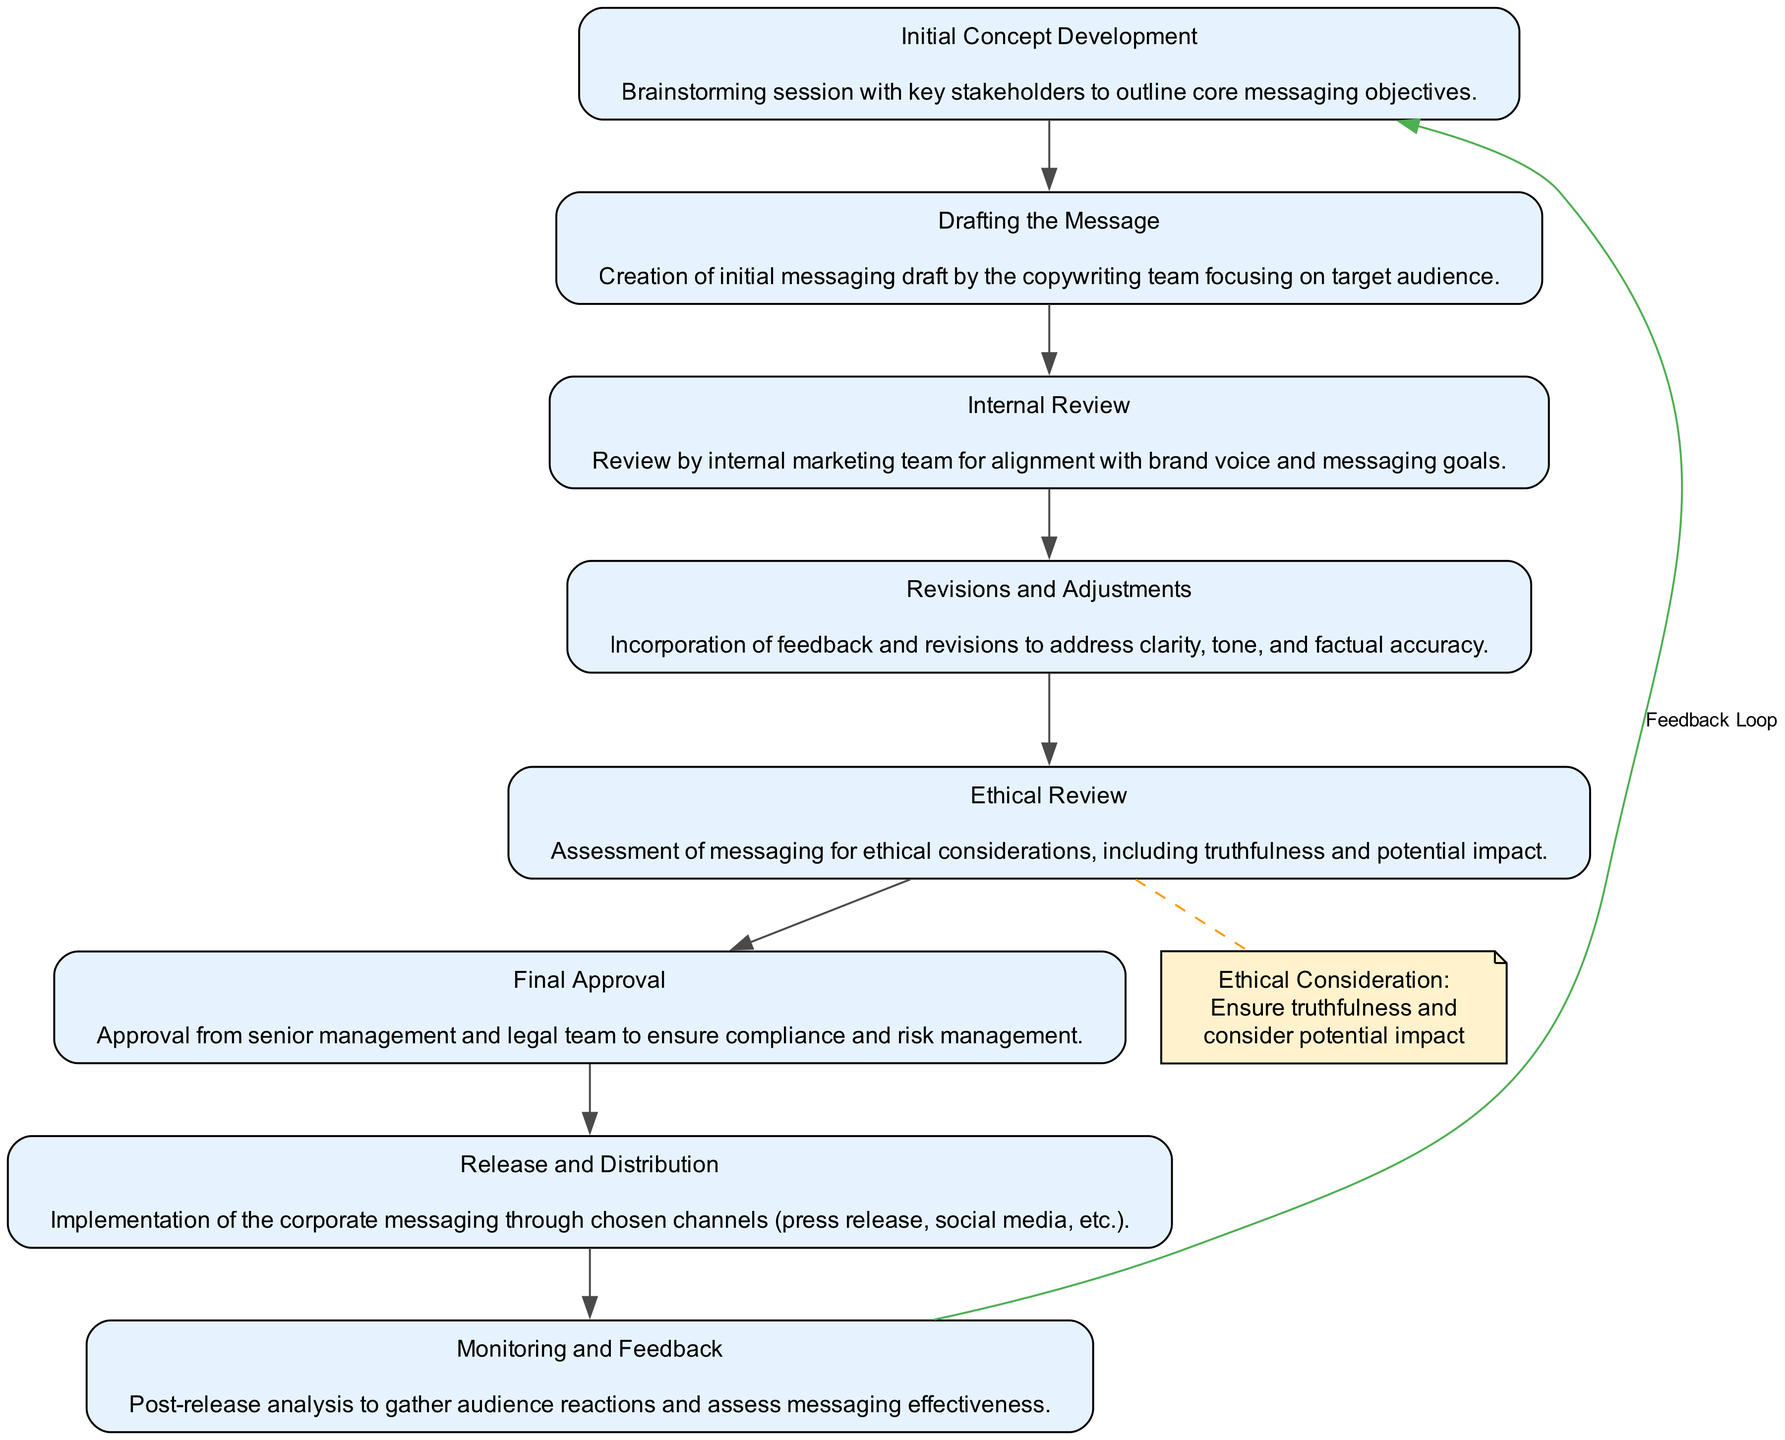What is the first stage in the corporate messaging process? The first stage listed in the flow chart is "Initial Concept Development". This can be found at the top of the diagram, indicating the starting point of the process.
Answer: Initial Concept Development How many total stages are involved in the corporate messaging process? By counting each stage listed in the diagram, we find there are eight stages in total shown in the flow chart.
Answer: 8 Which stage includes an ethical assessment of the messaging? The stage directly addressing ethical considerations is labeled "Ethical Review". It is the fifth stage in the flow chart, indicating its importance in the process.
Answer: Ethical Review What follows the "Revisions and Adjustments" stage? The stage following "Revisions and Adjustments" is "Ethical Review", as indicated by the flow of the diagram. This shows the progression in crafting the corporate message.
Answer: Ethical Review How is feedback integrated into the process after the "Release and Distribution"? A feedback loop is established from the "Monitoring and Feedback" stage back to "Initial Concept Development", allowing for continuous improvement based on audience reactions.
Answer: Feedback Loop What is the purpose of the dashed edge between "Revisions and Adjustments" and the ethical note? The dashed edge signifies that ethical considerations are reviewed after "Revisions and Adjustments", highlighting the need to ensure truthfulness and assess potential impact.
Answer: Ethical Consideration Who is responsible for the "Final Approval" stage? The "Final Approval" stage requires input from both senior management and the legal team, as specified in the description of that stage. This ensures compliance and risk management.
Answer: Senior management and legal team What happens during the "Monitoring and Feedback" stage? In this stage, there is post-release analysis to gather audience reactions and assess the effectiveness of the corporate messaging, completing the feedback loop.
Answer: Post-release analysis How does the diagram address ethical considerations in messaging? The diagram highlights ethical considerations specifically during the "Ethical Review" stage, with a focus on truthfulness and potential impact indicated by the ethical note.
Answer: Ethical Review 